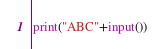Convert code to text. <code><loc_0><loc_0><loc_500><loc_500><_Python_>print("ABC"+input())</code> 